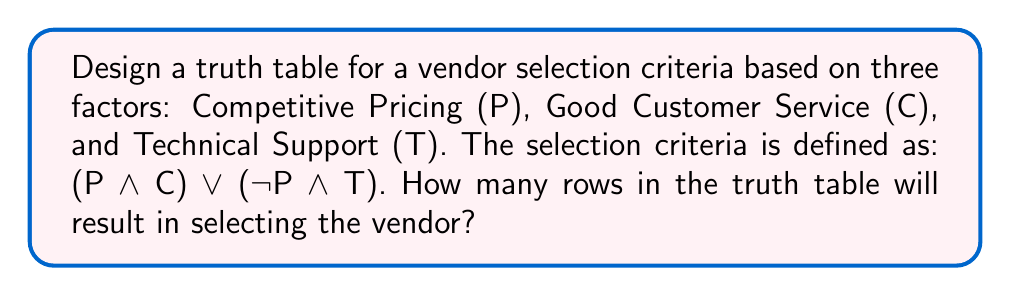Could you help me with this problem? Let's approach this step-by-step:

1) First, we need to create a truth table with all possible combinations of P, C, and T. Since we have 3 variables, we'll have $2^3 = 8$ rows.

2) Next, we'll evaluate the expression (P AND C) OR (NOT P AND T) for each row:

   $$(P \land C) \lor (\neg P \land T)$$

3) Let's create the truth table:

   | P | C | T | P ∧ C | ¬P | ¬P ∧ T | (P ∧ C) ∨ (¬P ∧ T) |
   |---|---|---|-------|----|---------|--------------------|
   | 0 | 0 | 0 |   0   |  1 |    0    |         0          |
   | 0 | 0 | 1 |   0   |  1 |    1    |         1          |
   | 0 | 1 | 0 |   0   |  1 |    0    |         0          |
   | 0 | 1 | 1 |   0   |  1 |    1    |         1          |
   | 1 | 0 | 0 |   0   |  0 |    0    |         0          |
   | 1 | 0 | 1 |   0   |  0 |    0    |         0          |
   | 1 | 1 | 0 |   1   |  0 |    0    |         1          |
   | 1 | 1 | 1 |   1   |  0 |    0    |         1          |

4) Now, we count the number of rows where the final column is 1. These are the cases where the vendor would be selected.

5) We can see that there are 4 rows where the result is 1.
Answer: 4 